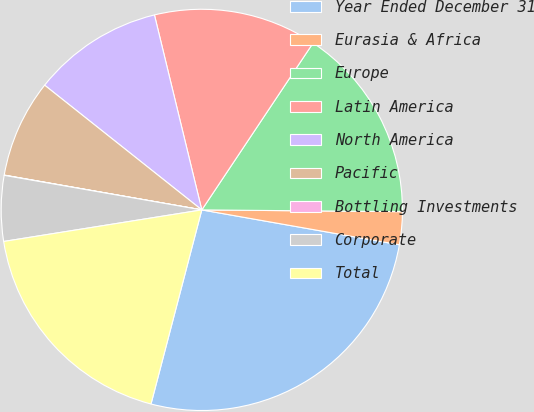Convert chart to OTSL. <chart><loc_0><loc_0><loc_500><loc_500><pie_chart><fcel>Year Ended December 31<fcel>Eurasia & Africa<fcel>Europe<fcel>Latin America<fcel>North America<fcel>Pacific<fcel>Bottling Investments<fcel>Corporate<fcel>Total<nl><fcel>26.29%<fcel>2.64%<fcel>15.78%<fcel>13.15%<fcel>10.53%<fcel>7.9%<fcel>0.02%<fcel>5.27%<fcel>18.41%<nl></chart> 